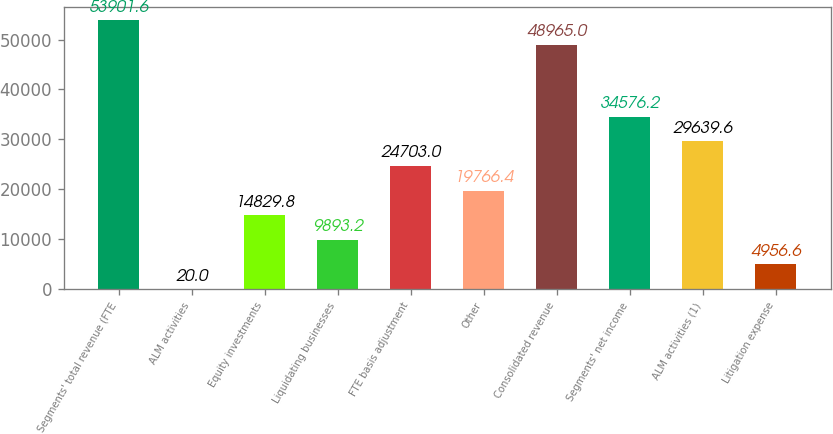Convert chart to OTSL. <chart><loc_0><loc_0><loc_500><loc_500><bar_chart><fcel>Segments' total revenue (FTE<fcel>ALM activities<fcel>Equity investments<fcel>Liquidating businesses<fcel>FTE basis adjustment<fcel>Other<fcel>Consolidated revenue<fcel>Segments' net income<fcel>ALM activities (1)<fcel>Litigation expense<nl><fcel>53901.6<fcel>20<fcel>14829.8<fcel>9893.2<fcel>24703<fcel>19766.4<fcel>48965<fcel>34576.2<fcel>29639.6<fcel>4956.6<nl></chart> 